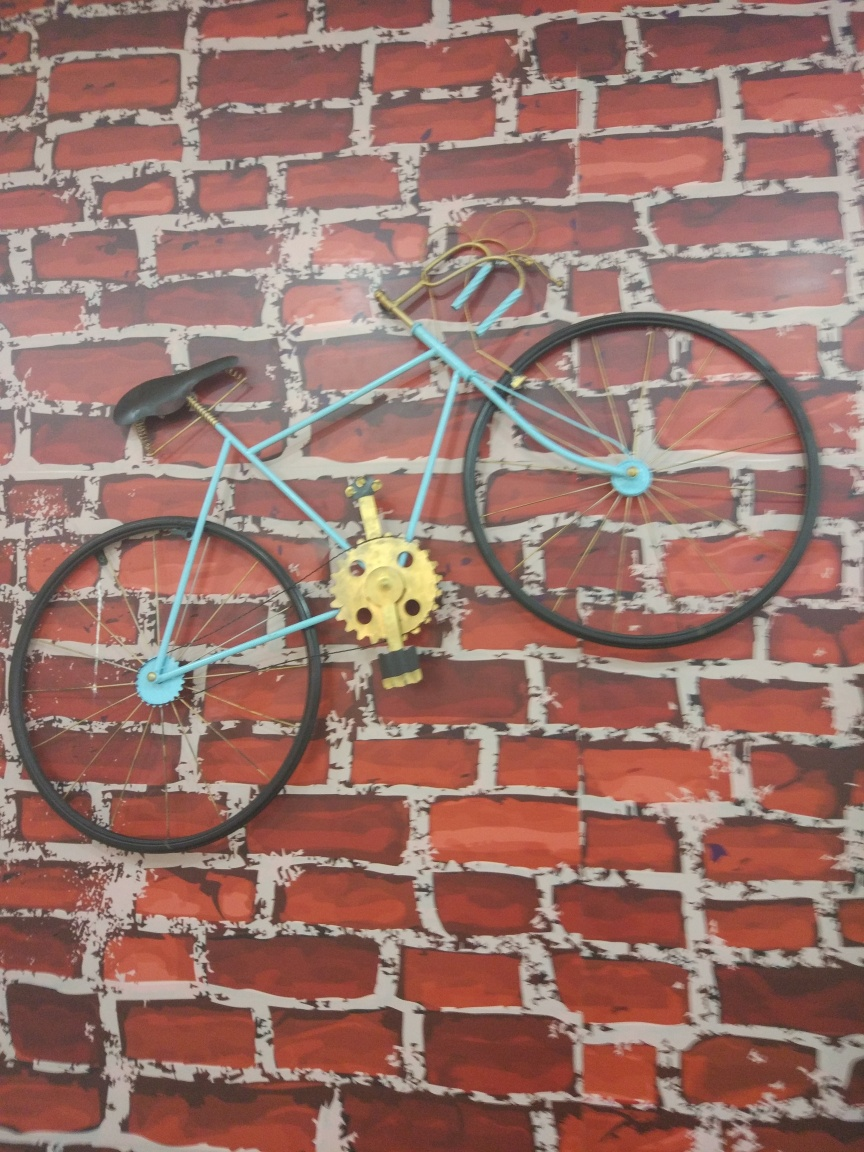What does the way the bicycle is displayed say about its role or the setting it is in? The bicycle being mounted on a wall, especially against a patterned backdrop that resembles a brick wall, indicates it is being used as wall art or a design feature rather than a mode of transportation. This type of display is often found in spaces that aim to evoke a certain ambiance or aesthetic, such as cafes, boutiques, or thematic interiors. It suggests a creative and perhaps nostalgic environment where the bike serves as a conversation piece or artistic installation. 